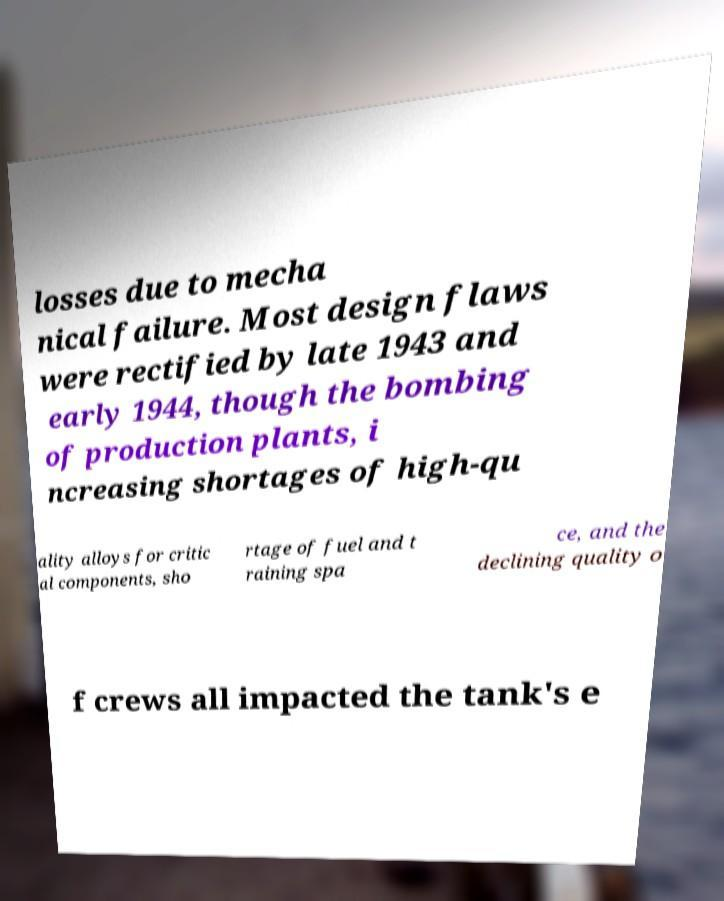For documentation purposes, I need the text within this image transcribed. Could you provide that? losses due to mecha nical failure. Most design flaws were rectified by late 1943 and early 1944, though the bombing of production plants, i ncreasing shortages of high-qu ality alloys for critic al components, sho rtage of fuel and t raining spa ce, and the declining quality o f crews all impacted the tank's e 